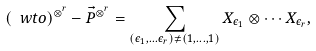<formula> <loc_0><loc_0><loc_500><loc_500>( \ w t o ) ^ { \otimes ^ { r } } - \vec { P } ^ { \otimes ^ { r } } = \sum _ { ( \epsilon _ { 1 } , \dots \epsilon _ { r } ) \neq ( 1 , \dots , 1 ) } X _ { \epsilon _ { 1 } } \otimes \cdots X _ { \epsilon _ { r } } ,</formula> 